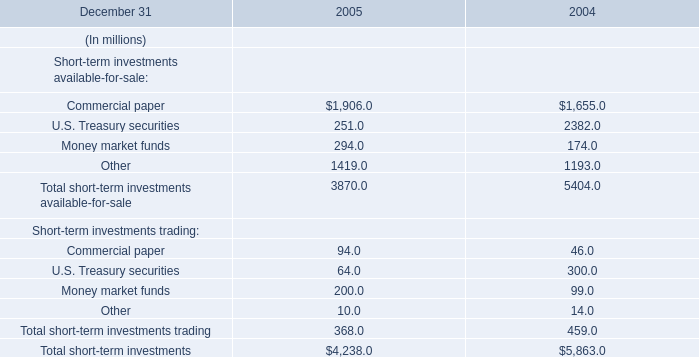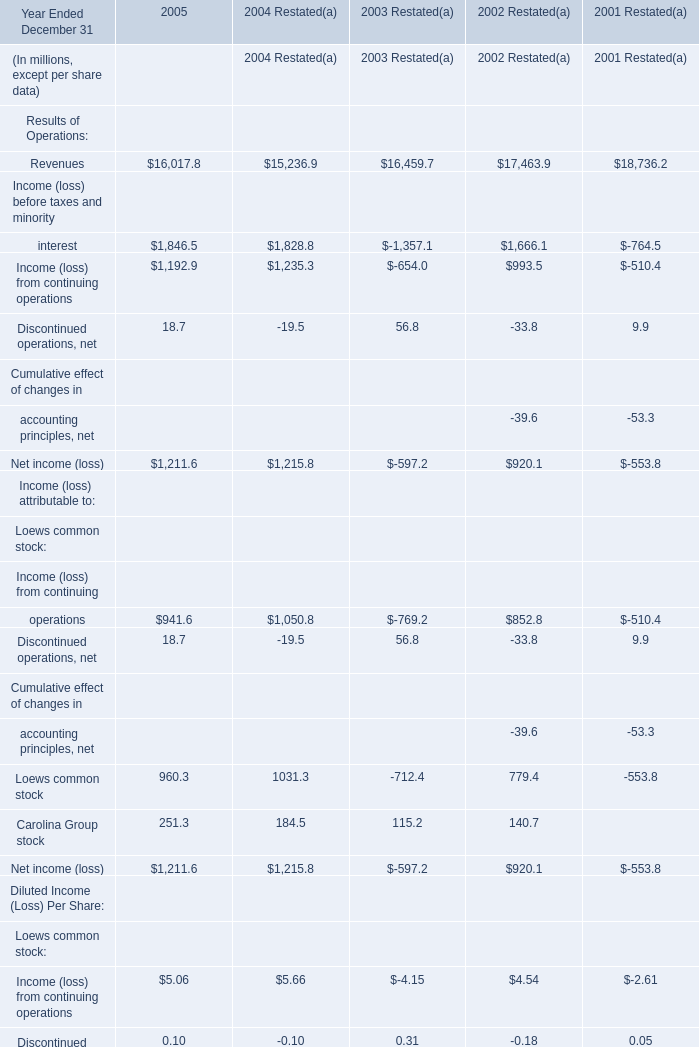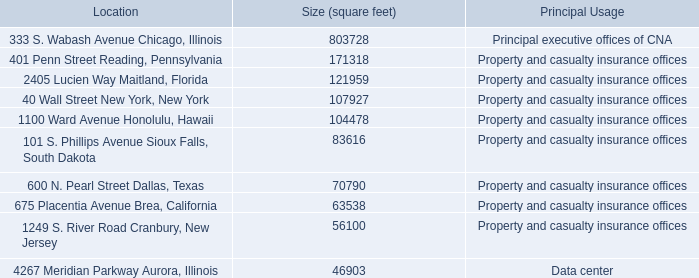What was the sum of Net income (loss) without Loews common stock in 2005 under the item of "Income (loss) attributable to: "? (in million) 
Answer: 251.3. 